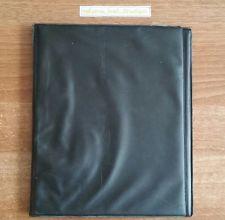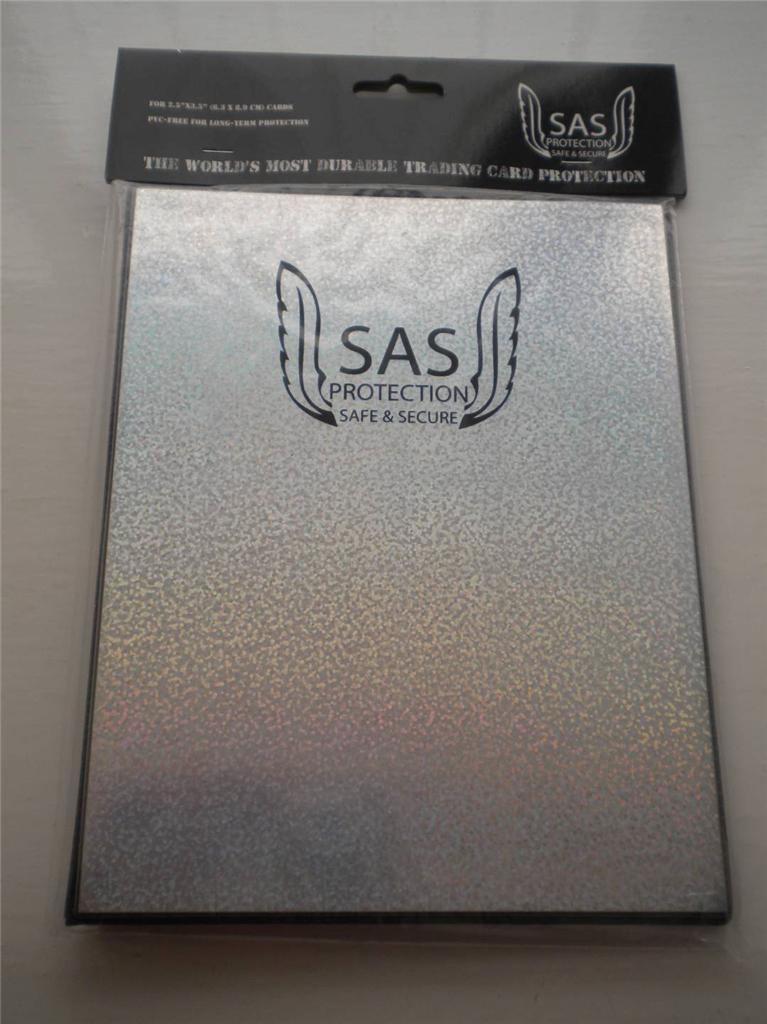The first image is the image on the left, the second image is the image on the right. For the images displayed, is the sentence "There is one red and one blue folder." factually correct? Answer yes or no. No. 